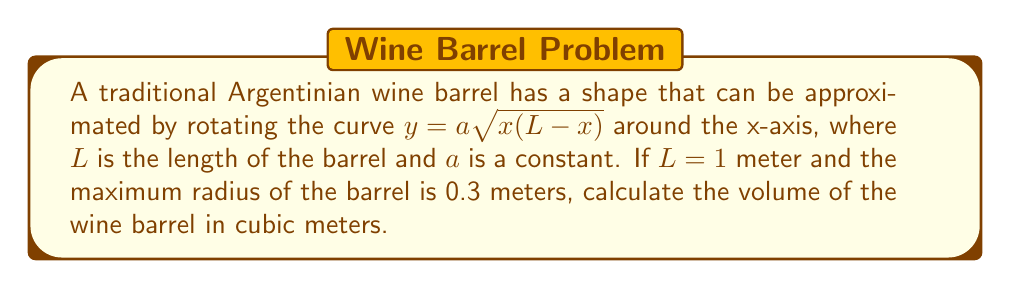Solve this math problem. Let's approach this step-by-step:

1) First, we need to determine the value of $a$. The maximum radius occurs at $x = L/2 = 0.5$ meters. So:

   $0.3 = a\sqrt{0.5(1-0.5)}$
   $0.3 = a\sqrt{0.25}$
   $0.3 = 0.5a$
   $a = 0.6$

2) Now that we have $a$, our curve is $y = 0.6\sqrt{x(1-x)}$

3) To find the volume, we need to use the formula for the volume of a solid of revolution:

   $V = \pi \int_0^L y^2 dx$

4) Substituting our function:

   $V = \pi \int_0^1 (0.6\sqrt{x(1-x)})^2 dx$

5) Simplifying:

   $V = 0.36\pi \int_0^1 x(1-x) dx$

6) Expanding:

   $V = 0.36\pi \int_0^1 (x - x^2) dx$

7) Integrating:

   $V = 0.36\pi [\frac{x^2}{2} - \frac{x^3}{3}]_0^1$

8) Evaluating the bounds:

   $V = 0.36\pi (\frac{1}{2} - \frac{1}{3})$

9) Simplifying:

   $V = 0.36\pi (\frac{1}{6}) = 0.06\pi$

10) Calculating the final result:

    $V \approx 0.1885$ cubic meters
Answer: $0.1885$ m³ 